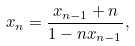Convert formula to latex. <formula><loc_0><loc_0><loc_500><loc_500>x _ { n } = \frac { x _ { n - 1 } + n } { 1 - n x _ { n - 1 } } ,</formula> 